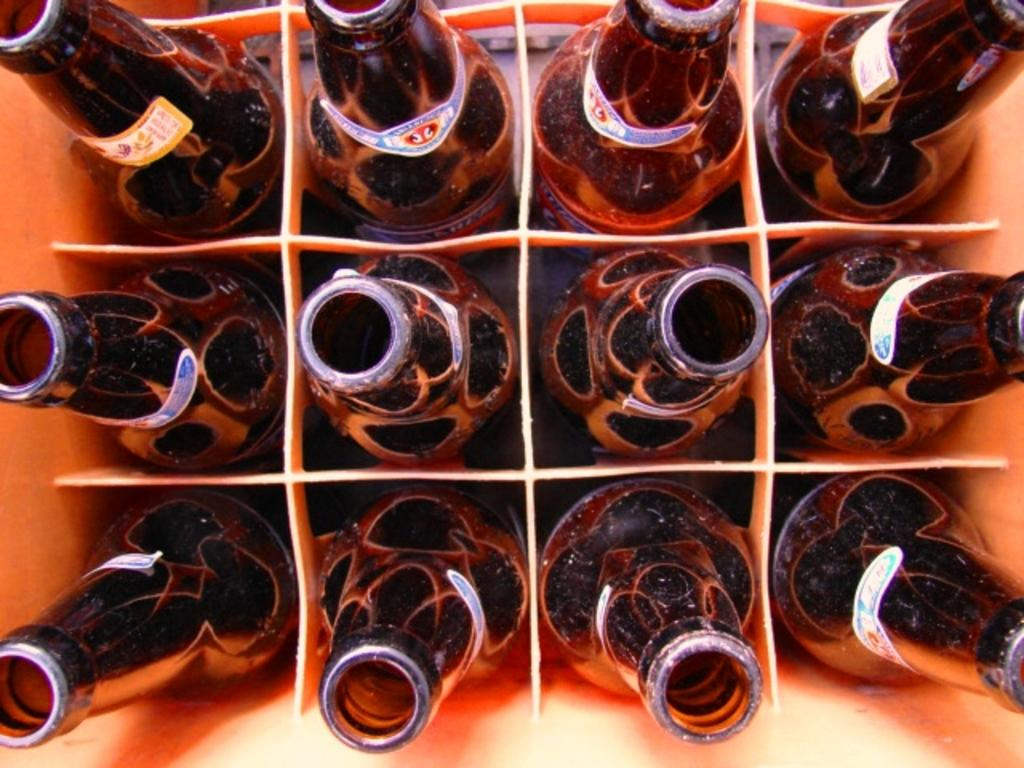What objects are present in the image? There are bottles in the image. What can be seen on the bottles? The bottles have labels on them. How are the bottles arranged in the image? The bottles are in a plastic tray. What song is being played by the bottles in the image? There is no song being played by the bottles in the image; they are simply bottles with labels in a plastic tray. 